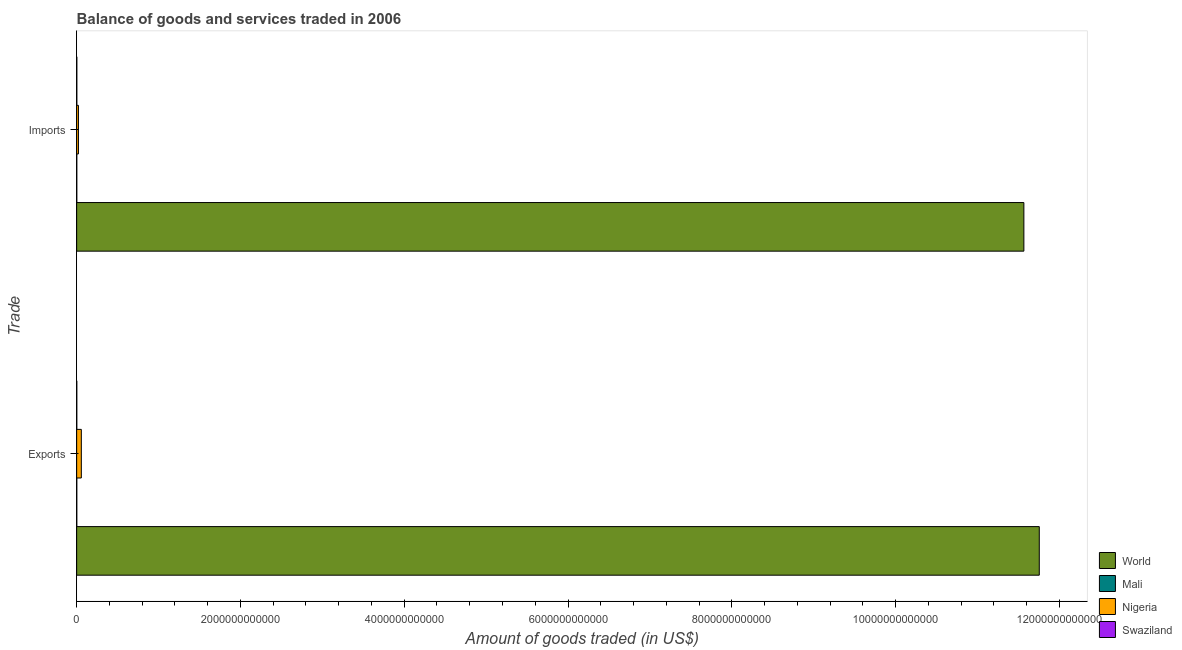How many different coloured bars are there?
Provide a succinct answer. 4. How many bars are there on the 2nd tick from the top?
Provide a succinct answer. 4. How many bars are there on the 2nd tick from the bottom?
Offer a very short reply. 4. What is the label of the 1st group of bars from the top?
Offer a terse response. Imports. What is the amount of goods exported in Mali?
Give a very brief answer. 1.55e+09. Across all countries, what is the maximum amount of goods exported?
Your answer should be very brief. 1.18e+13. Across all countries, what is the minimum amount of goods imported?
Ensure brevity in your answer.  1.47e+09. In which country was the amount of goods exported maximum?
Offer a very short reply. World. In which country was the amount of goods imported minimum?
Your answer should be compact. Mali. What is the total amount of goods imported in the graph?
Ensure brevity in your answer.  1.16e+13. What is the difference between the amount of goods exported in Swaziland and that in World?
Ensure brevity in your answer.  -1.18e+13. What is the difference between the amount of goods imported in Swaziland and the amount of goods exported in Mali?
Your answer should be very brief. 2.56e+08. What is the average amount of goods exported per country?
Your answer should be compact. 2.95e+12. What is the difference between the amount of goods exported and amount of goods imported in World?
Ensure brevity in your answer.  1.88e+11. In how many countries, is the amount of goods imported greater than 6000000000000 US$?
Ensure brevity in your answer.  1. What is the ratio of the amount of goods exported in Swaziland to that in Nigeria?
Your answer should be very brief. 0.03. Is the amount of goods imported in Mali less than that in World?
Offer a very short reply. Yes. In how many countries, is the amount of goods imported greater than the average amount of goods imported taken over all countries?
Provide a succinct answer. 1. What does the 4th bar from the top in Exports represents?
Ensure brevity in your answer.  World. What does the 2nd bar from the bottom in Imports represents?
Make the answer very short. Mali. How many bars are there?
Keep it short and to the point. 8. What is the difference between two consecutive major ticks on the X-axis?
Offer a very short reply. 2.00e+12. Are the values on the major ticks of X-axis written in scientific E-notation?
Make the answer very short. No. Does the graph contain grids?
Provide a short and direct response. No. How many legend labels are there?
Offer a very short reply. 4. What is the title of the graph?
Make the answer very short. Balance of goods and services traded in 2006. Does "Namibia" appear as one of the legend labels in the graph?
Make the answer very short. No. What is the label or title of the X-axis?
Your answer should be very brief. Amount of goods traded (in US$). What is the label or title of the Y-axis?
Your response must be concise. Trade. What is the Amount of goods traded (in US$) in World in Exports?
Your answer should be very brief. 1.18e+13. What is the Amount of goods traded (in US$) in Mali in Exports?
Your response must be concise. 1.55e+09. What is the Amount of goods traded (in US$) of Nigeria in Exports?
Your answer should be compact. 5.69e+1. What is the Amount of goods traded (in US$) of Swaziland in Exports?
Make the answer very short. 1.56e+09. What is the Amount of goods traded (in US$) of World in Imports?
Ensure brevity in your answer.  1.16e+13. What is the Amount of goods traded (in US$) of Mali in Imports?
Make the answer very short. 1.47e+09. What is the Amount of goods traded (in US$) of Nigeria in Imports?
Your response must be concise. 2.20e+1. What is the Amount of goods traded (in US$) of Swaziland in Imports?
Offer a very short reply. 1.81e+09. Across all Trade, what is the maximum Amount of goods traded (in US$) of World?
Give a very brief answer. 1.18e+13. Across all Trade, what is the maximum Amount of goods traded (in US$) of Mali?
Keep it short and to the point. 1.55e+09. Across all Trade, what is the maximum Amount of goods traded (in US$) in Nigeria?
Make the answer very short. 5.69e+1. Across all Trade, what is the maximum Amount of goods traded (in US$) in Swaziland?
Ensure brevity in your answer.  1.81e+09. Across all Trade, what is the minimum Amount of goods traded (in US$) in World?
Provide a succinct answer. 1.16e+13. Across all Trade, what is the minimum Amount of goods traded (in US$) of Mali?
Keep it short and to the point. 1.47e+09. Across all Trade, what is the minimum Amount of goods traded (in US$) of Nigeria?
Ensure brevity in your answer.  2.20e+1. Across all Trade, what is the minimum Amount of goods traded (in US$) in Swaziland?
Provide a short and direct response. 1.56e+09. What is the total Amount of goods traded (in US$) of World in the graph?
Provide a short and direct response. 2.33e+13. What is the total Amount of goods traded (in US$) of Mali in the graph?
Provide a short and direct response. 3.02e+09. What is the total Amount of goods traded (in US$) of Nigeria in the graph?
Your response must be concise. 7.89e+1. What is the total Amount of goods traded (in US$) in Swaziland in the graph?
Your answer should be very brief. 3.37e+09. What is the difference between the Amount of goods traded (in US$) in World in Exports and that in Imports?
Make the answer very short. 1.88e+11. What is the difference between the Amount of goods traded (in US$) of Mali in Exports and that in Imports?
Provide a short and direct response. 7.71e+07. What is the difference between the Amount of goods traded (in US$) of Nigeria in Exports and that in Imports?
Ensure brevity in your answer.  3.49e+1. What is the difference between the Amount of goods traded (in US$) of Swaziland in Exports and that in Imports?
Your answer should be very brief. -2.46e+08. What is the difference between the Amount of goods traded (in US$) in World in Exports and the Amount of goods traded (in US$) in Mali in Imports?
Give a very brief answer. 1.18e+13. What is the difference between the Amount of goods traded (in US$) in World in Exports and the Amount of goods traded (in US$) in Nigeria in Imports?
Make the answer very short. 1.17e+13. What is the difference between the Amount of goods traded (in US$) in World in Exports and the Amount of goods traded (in US$) in Swaziland in Imports?
Your answer should be very brief. 1.18e+13. What is the difference between the Amount of goods traded (in US$) of Mali in Exports and the Amount of goods traded (in US$) of Nigeria in Imports?
Your answer should be very brief. -2.04e+1. What is the difference between the Amount of goods traded (in US$) of Mali in Exports and the Amount of goods traded (in US$) of Swaziland in Imports?
Offer a very short reply. -2.56e+08. What is the difference between the Amount of goods traded (in US$) of Nigeria in Exports and the Amount of goods traded (in US$) of Swaziland in Imports?
Provide a short and direct response. 5.51e+1. What is the average Amount of goods traded (in US$) of World per Trade?
Give a very brief answer. 1.17e+13. What is the average Amount of goods traded (in US$) in Mali per Trade?
Provide a short and direct response. 1.51e+09. What is the average Amount of goods traded (in US$) in Nigeria per Trade?
Give a very brief answer. 3.95e+1. What is the average Amount of goods traded (in US$) of Swaziland per Trade?
Offer a terse response. 1.68e+09. What is the difference between the Amount of goods traded (in US$) of World and Amount of goods traded (in US$) of Mali in Exports?
Offer a terse response. 1.18e+13. What is the difference between the Amount of goods traded (in US$) in World and Amount of goods traded (in US$) in Nigeria in Exports?
Offer a terse response. 1.17e+13. What is the difference between the Amount of goods traded (in US$) of World and Amount of goods traded (in US$) of Swaziland in Exports?
Ensure brevity in your answer.  1.18e+13. What is the difference between the Amount of goods traded (in US$) of Mali and Amount of goods traded (in US$) of Nigeria in Exports?
Keep it short and to the point. -5.54e+1. What is the difference between the Amount of goods traded (in US$) of Mali and Amount of goods traded (in US$) of Swaziland in Exports?
Your response must be concise. -1.03e+07. What is the difference between the Amount of goods traded (in US$) of Nigeria and Amount of goods traded (in US$) of Swaziland in Exports?
Your response must be concise. 5.54e+1. What is the difference between the Amount of goods traded (in US$) in World and Amount of goods traded (in US$) in Mali in Imports?
Keep it short and to the point. 1.16e+13. What is the difference between the Amount of goods traded (in US$) in World and Amount of goods traded (in US$) in Nigeria in Imports?
Your answer should be compact. 1.15e+13. What is the difference between the Amount of goods traded (in US$) in World and Amount of goods traded (in US$) in Swaziland in Imports?
Your answer should be very brief. 1.16e+13. What is the difference between the Amount of goods traded (in US$) in Mali and Amount of goods traded (in US$) in Nigeria in Imports?
Offer a very short reply. -2.05e+1. What is the difference between the Amount of goods traded (in US$) of Mali and Amount of goods traded (in US$) of Swaziland in Imports?
Provide a succinct answer. -3.33e+08. What is the difference between the Amount of goods traded (in US$) in Nigeria and Amount of goods traded (in US$) in Swaziland in Imports?
Offer a very short reply. 2.02e+1. What is the ratio of the Amount of goods traded (in US$) in World in Exports to that in Imports?
Your answer should be very brief. 1.02. What is the ratio of the Amount of goods traded (in US$) of Mali in Exports to that in Imports?
Give a very brief answer. 1.05. What is the ratio of the Amount of goods traded (in US$) in Nigeria in Exports to that in Imports?
Keep it short and to the point. 2.59. What is the ratio of the Amount of goods traded (in US$) of Swaziland in Exports to that in Imports?
Give a very brief answer. 0.86. What is the difference between the highest and the second highest Amount of goods traded (in US$) in World?
Your response must be concise. 1.88e+11. What is the difference between the highest and the second highest Amount of goods traded (in US$) in Mali?
Make the answer very short. 7.71e+07. What is the difference between the highest and the second highest Amount of goods traded (in US$) in Nigeria?
Your answer should be compact. 3.49e+1. What is the difference between the highest and the second highest Amount of goods traded (in US$) in Swaziland?
Give a very brief answer. 2.46e+08. What is the difference between the highest and the lowest Amount of goods traded (in US$) of World?
Provide a short and direct response. 1.88e+11. What is the difference between the highest and the lowest Amount of goods traded (in US$) of Mali?
Make the answer very short. 7.71e+07. What is the difference between the highest and the lowest Amount of goods traded (in US$) of Nigeria?
Your answer should be compact. 3.49e+1. What is the difference between the highest and the lowest Amount of goods traded (in US$) of Swaziland?
Your answer should be compact. 2.46e+08. 